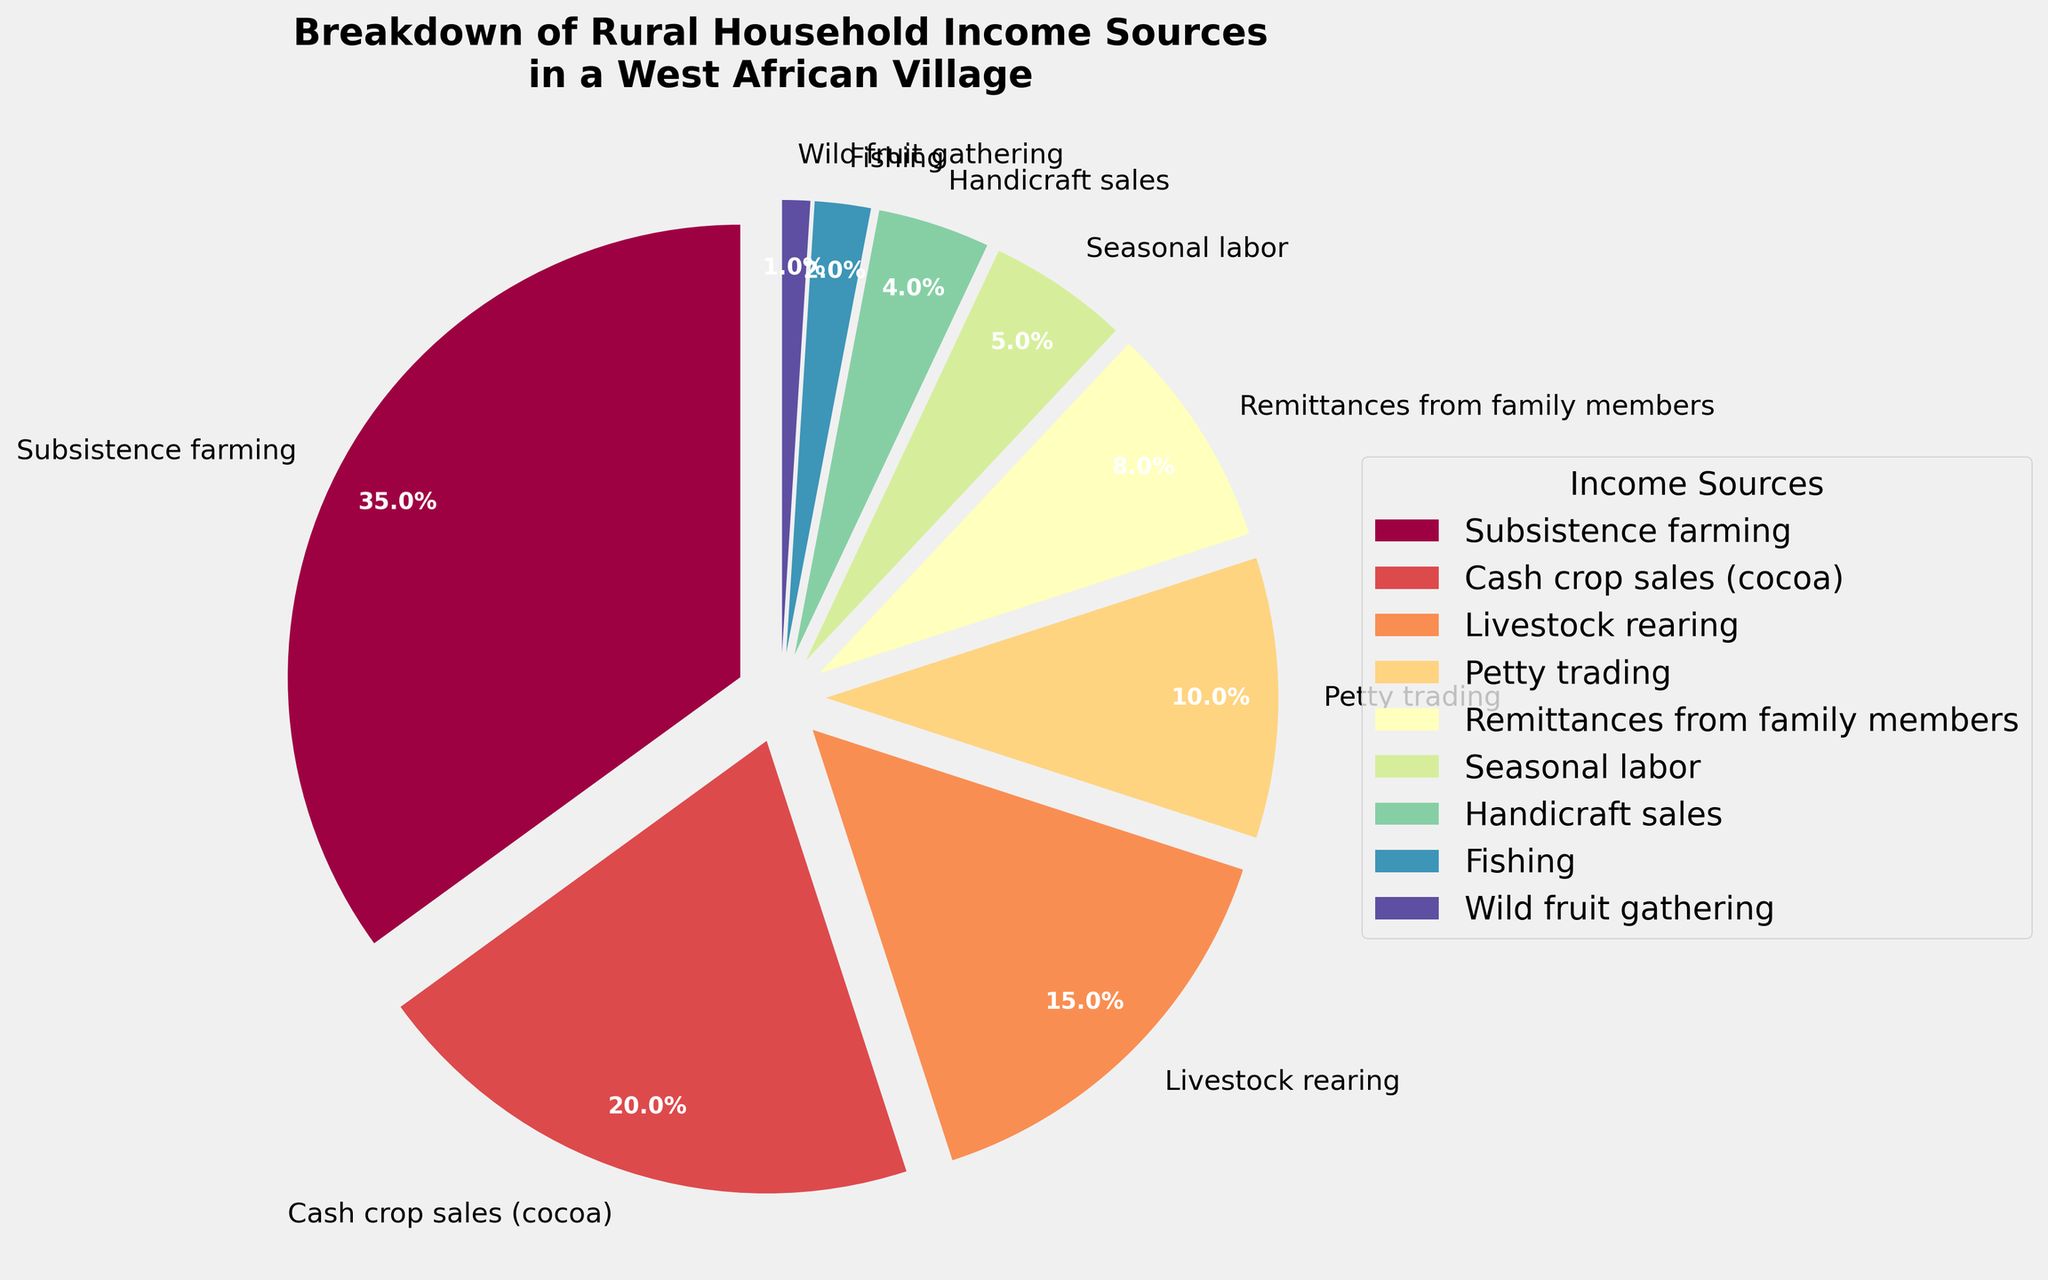Which income source has the highest percentage? The pie chart's largest segment indicates the income source with the highest percentage. The largest segment corresponds to subsistence farming, which is 35%.
Answer: Subsistence farming Which income source contributes the least to the household income? The pie chart's smallest segment represents the income source with the lowest percentage. The smallest segment is wild fruit gathering, which is 1%.
Answer: Wild fruit gathering How much more does subsistence farming contribute compared to cash crop sales (cocoa)? Subsistence farming contributes 35%, and cash crop sales (cocoa) contribute 20%. The difference is calculated as 35% - 20%.
Answer: 15% What percentage of household income comes from activities other than subsistence farming and cash crop sales (cocoa)? Total percentage is 100%. Subtracting the contributions from subsistence farming (35%) and cash crop sales (cocoa) (20%) gives 100% - 35% - 20%.
Answer: 45% What is the combined percentage of income derived from seasonal labor, handicraft sales, and fishing? Summing the percentages of seasonal labor (5%), handicraft sales (4%), and fishing (2%) gives 5% + 4% + 2%.
Answer: 11% Which category, petty trading or livestock rearing, contributes a larger share, and by how much? Petty trading contributes 10% and livestock rearing contributes 15%. The difference is 15% - 10%.
Answer: Livestock rearing by 5% What is the total percentage of household income from remittances and petty trading? Adding the percentages from remittances (8%) and petty trading (10%) gives 8% + 10%.
Answer: 18% Compare the contributions of fishing and wild fruit gathering. Which contributes more and by how much? Fishing contributes 2% and wild fruit gathering contributes 1%. The difference is 2% - 1%.
Answer: Fishing by 1% How does the income from livestock rearing compare to the total income from petty trading, remittances, and handicraft sales combined? Livestock rearing contributes 15%. The combined percentage from petty trading (10%), remittances (8%), and handicraft sales (4%) is 10% + 8% + 4% = 22%.
Answer: Less by 7% Which two income sources together account for 50% of the household income, if any? Summing different income sources: subsistence farming (35%) and cash crop sales (20%) are the only two that sum up to more than 50%, specifically 55%. No exactly 50% combination is possible.
Answer: None 